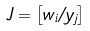Convert formula to latex. <formula><loc_0><loc_0><loc_500><loc_500>J = \left [ w _ { i } / y _ { j } \right ]</formula> 